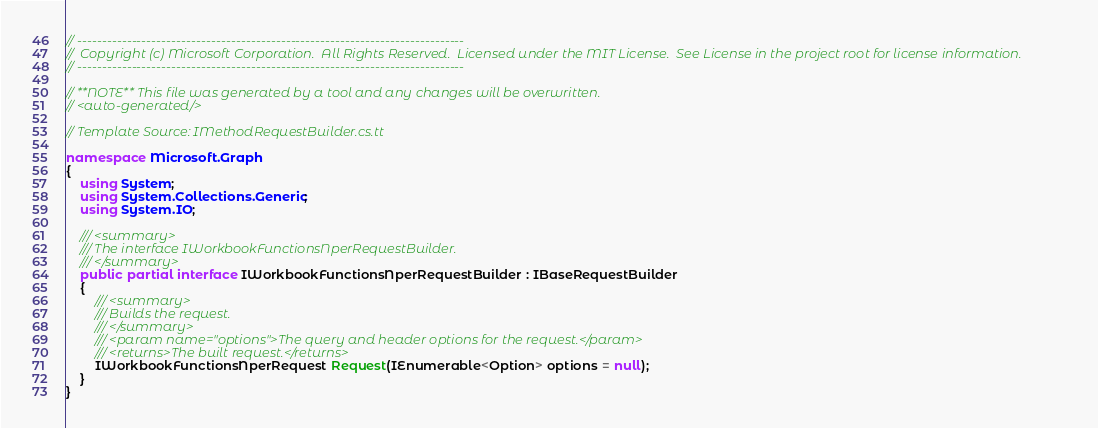Convert code to text. <code><loc_0><loc_0><loc_500><loc_500><_C#_>// ------------------------------------------------------------------------------
//  Copyright (c) Microsoft Corporation.  All Rights Reserved.  Licensed under the MIT License.  See License in the project root for license information.
// ------------------------------------------------------------------------------

// **NOTE** This file was generated by a tool and any changes will be overwritten.
// <auto-generated/>

// Template Source: IMethodRequestBuilder.cs.tt

namespace Microsoft.Graph
{
    using System;
    using System.Collections.Generic;
    using System.IO;

    /// <summary>
    /// The interface IWorkbookFunctionsNperRequestBuilder.
    /// </summary>
    public partial interface IWorkbookFunctionsNperRequestBuilder : IBaseRequestBuilder
    {
        /// <summary>
        /// Builds the request.
        /// </summary>
        /// <param name="options">The query and header options for the request.</param>
        /// <returns>The built request.</returns>
        IWorkbookFunctionsNperRequest Request(IEnumerable<Option> options = null);
    }
}
</code> 